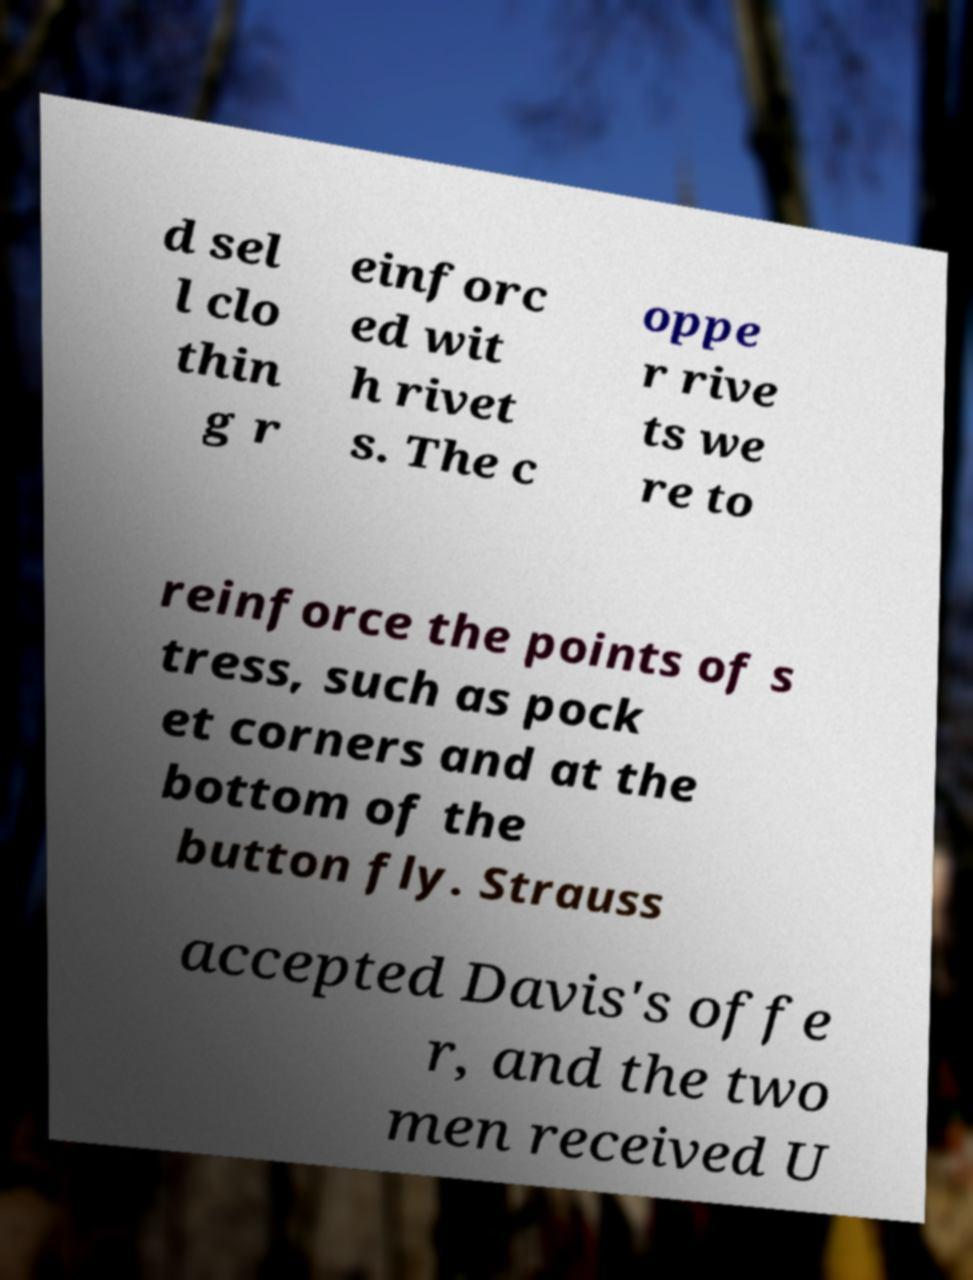What messages or text are displayed in this image? I need them in a readable, typed format. d sel l clo thin g r einforc ed wit h rivet s. The c oppe r rive ts we re to reinforce the points of s tress, such as pock et corners and at the bottom of the button fly. Strauss accepted Davis's offe r, and the two men received U 